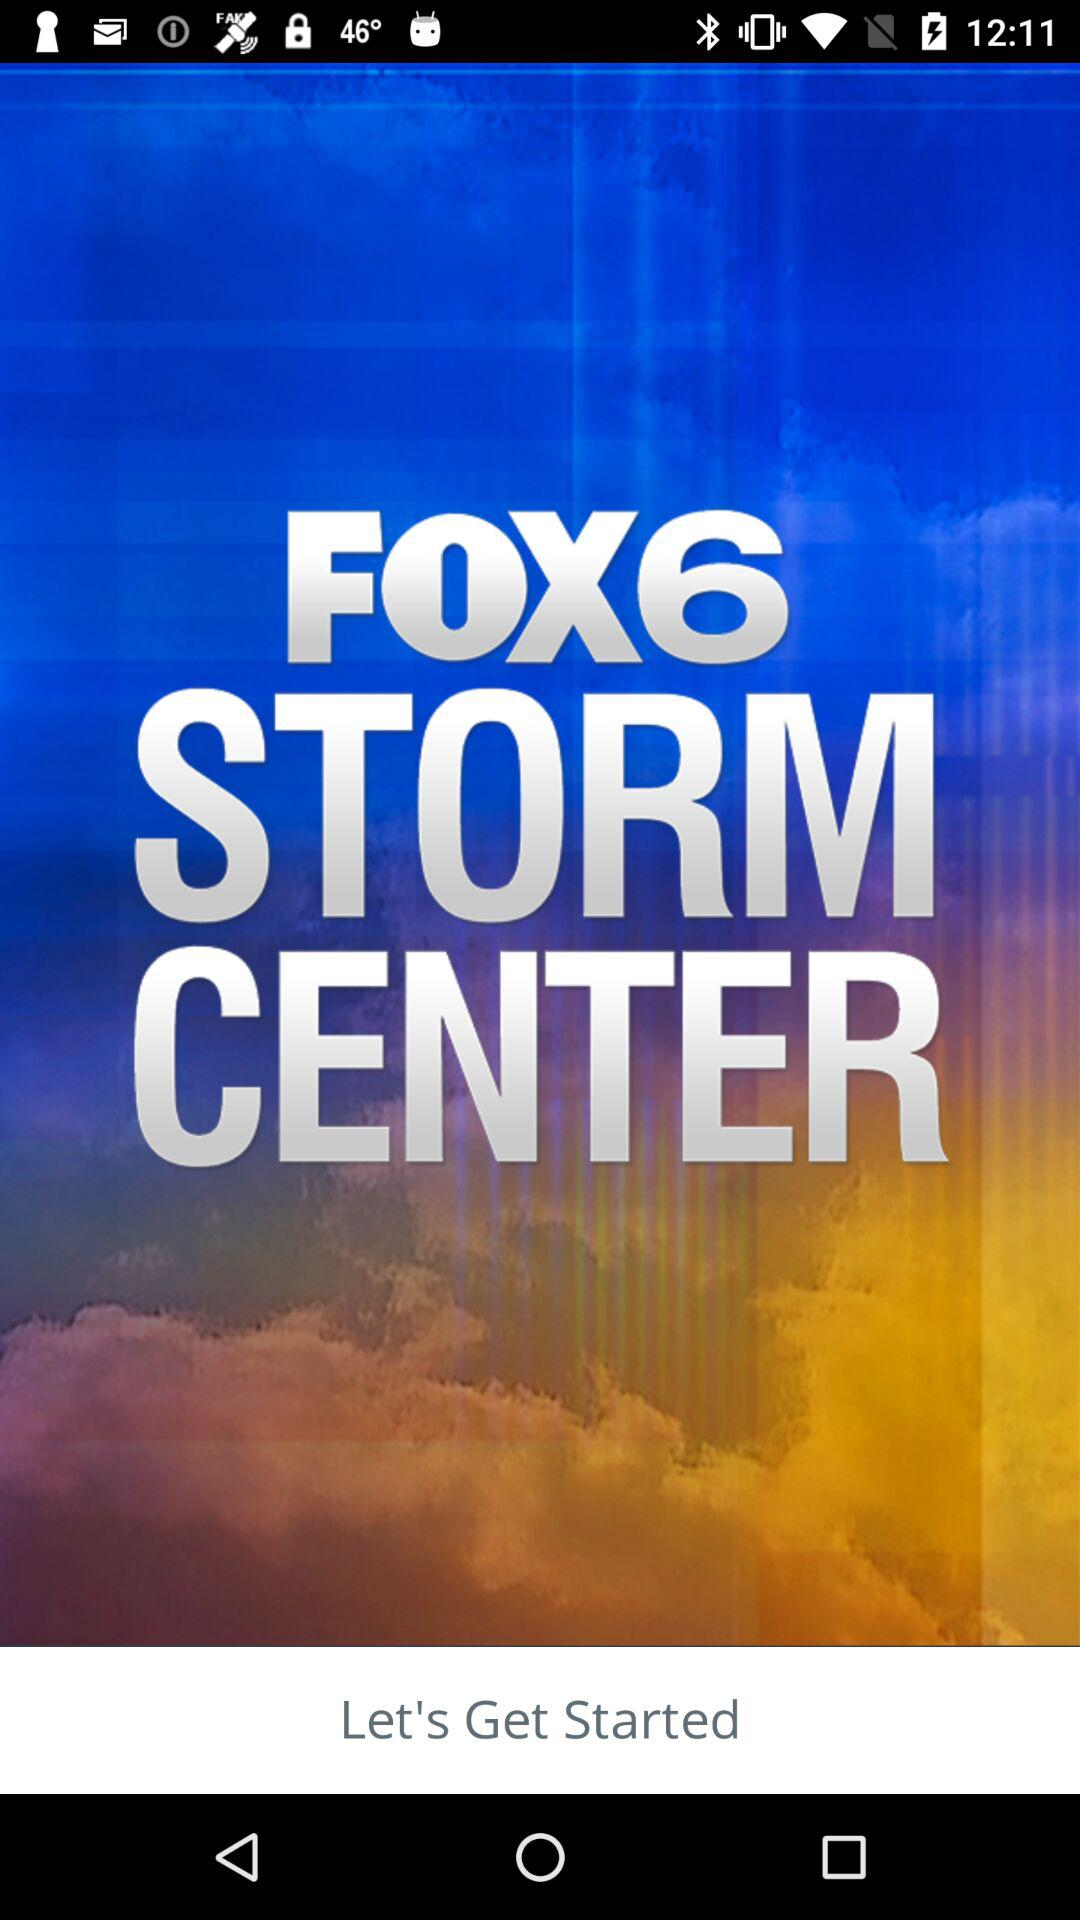What is the name of the application? The name of the application is "FOX6 STORM CENTER". 